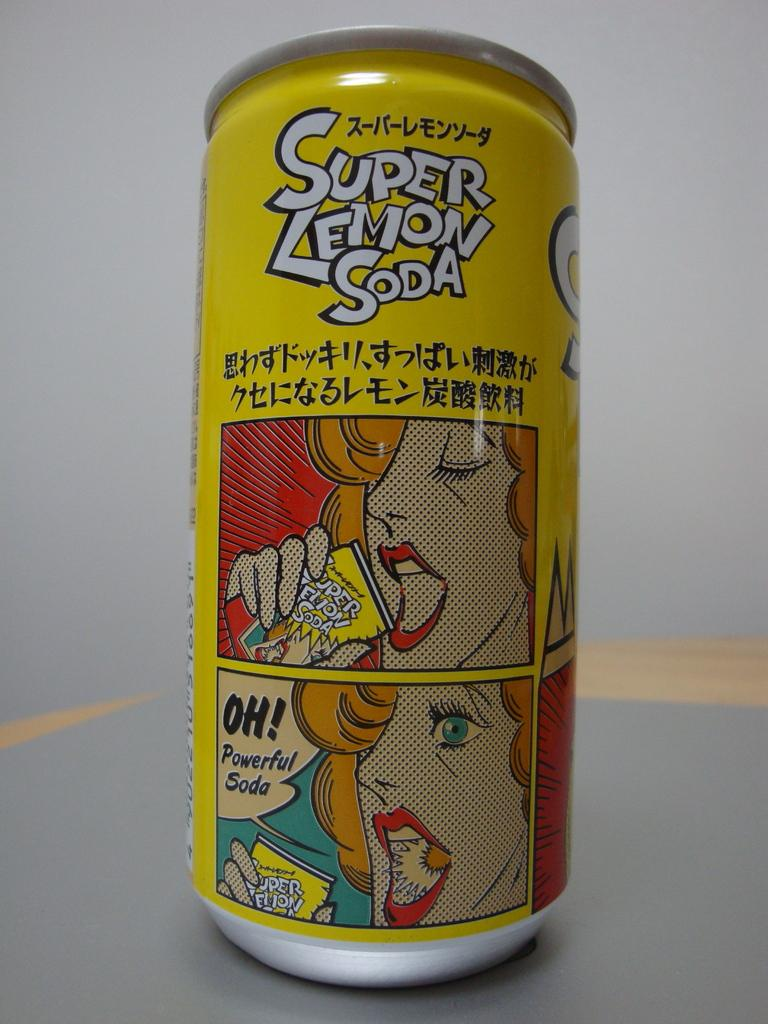<image>
Render a clear and concise summary of the photo. A yellow aluminum can of Super Lemon Soda on a flat surface. 